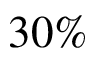<formula> <loc_0><loc_0><loc_500><loc_500>3 0 \%</formula> 